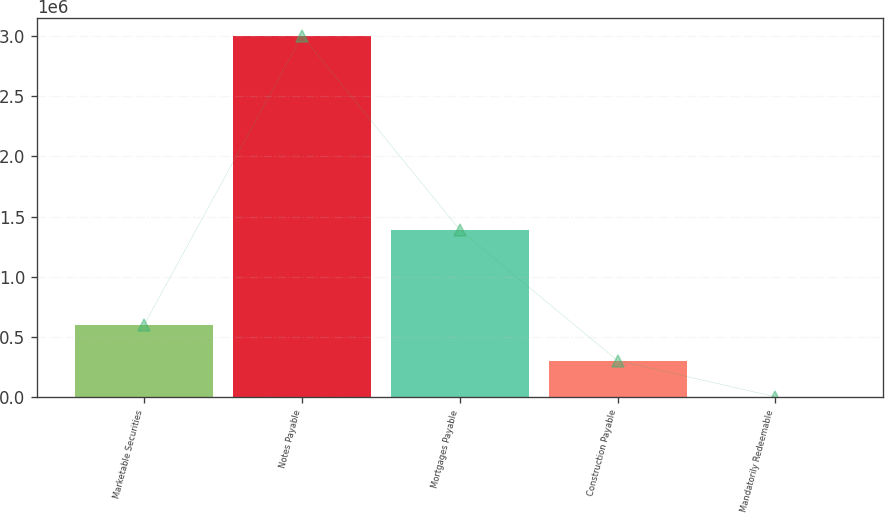<chart> <loc_0><loc_0><loc_500><loc_500><bar_chart><fcel>Marketable Securities<fcel>Notes Payable<fcel>Mortgages Payable<fcel>Construction Payable<fcel>Mandatorily Redeemable<nl><fcel>602275<fcel>3.0003e+06<fcel>1.38826e+06<fcel>302522<fcel>2768<nl></chart> 